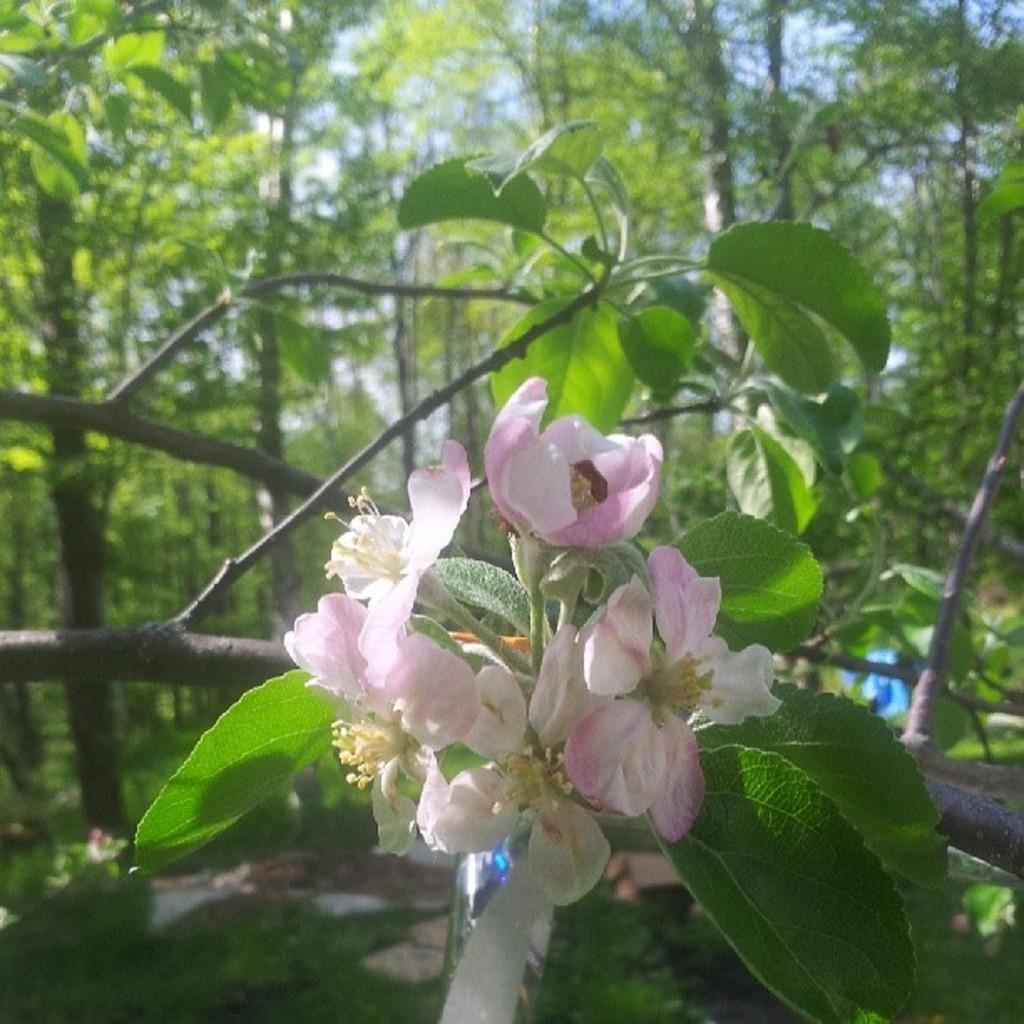What type of plants can be seen in the image? There are flowers in the image. What part of the plants can be seen in the image? There are leaves on the branches in the image. What can be seen in the background of the image? Trees and the sky are visible in the background of the image. What type of wax is used to create the caption on the image? There is no caption present in the image, so there is no wax used for it. How does the transport system function in the image? There is no transport system depicted in the image, so it cannot be described. 